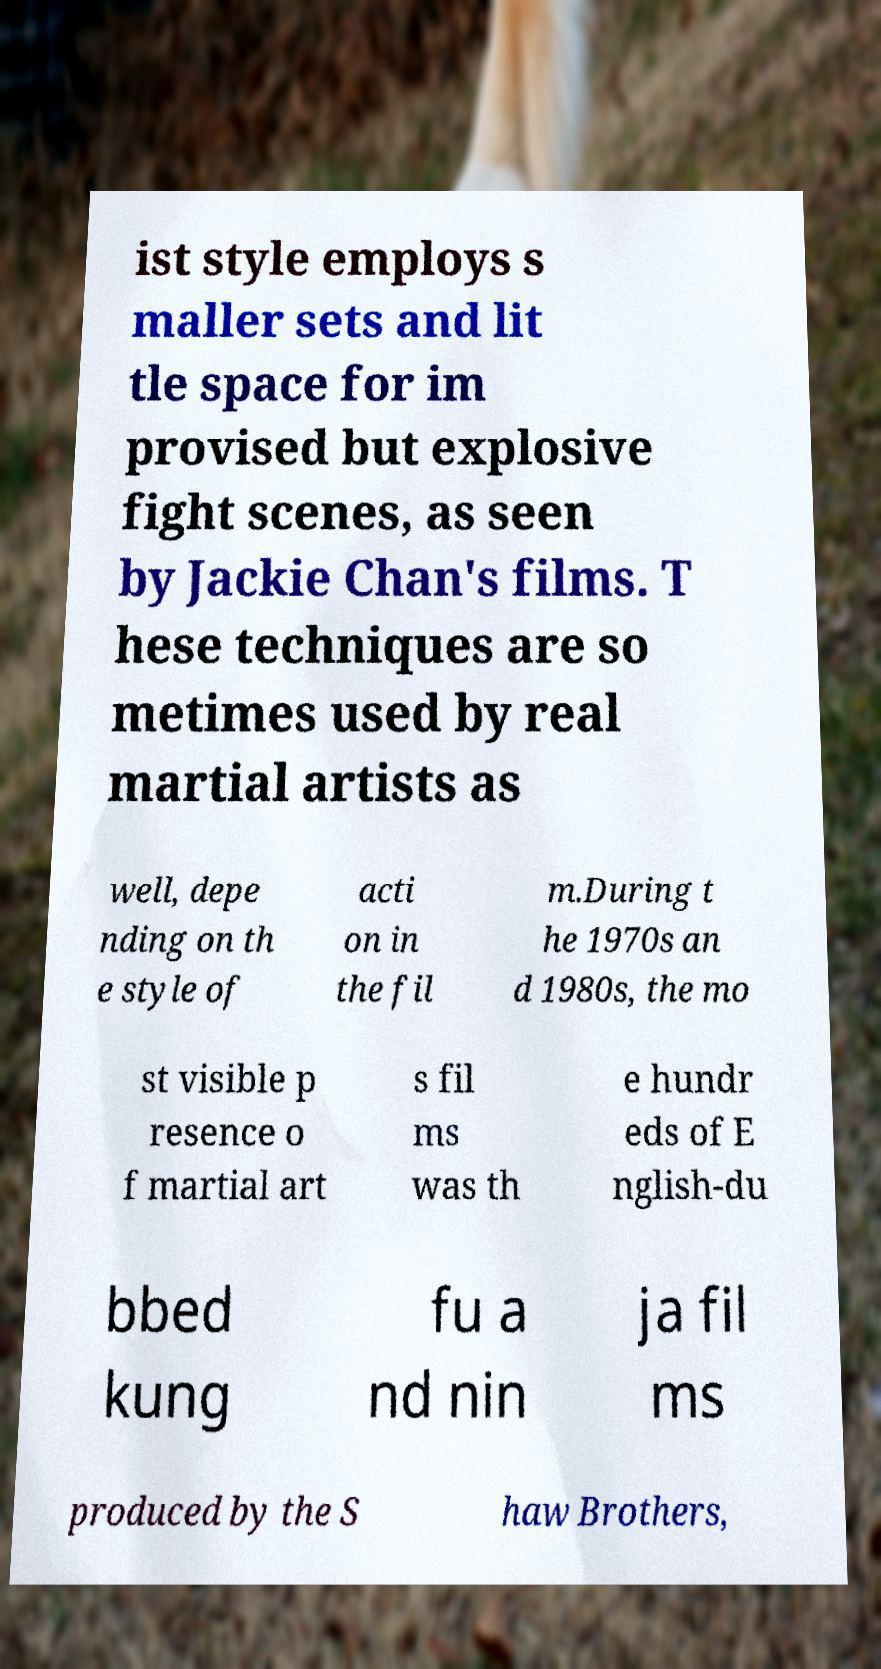Could you assist in decoding the text presented in this image and type it out clearly? ist style employs s maller sets and lit tle space for im provised but explosive fight scenes, as seen by Jackie Chan's films. T hese techniques are so metimes used by real martial artists as well, depe nding on th e style of acti on in the fil m.During t he 1970s an d 1980s, the mo st visible p resence o f martial art s fil ms was th e hundr eds of E nglish-du bbed kung fu a nd nin ja fil ms produced by the S haw Brothers, 